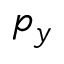<formula> <loc_0><loc_0><loc_500><loc_500>p _ { y }</formula> 